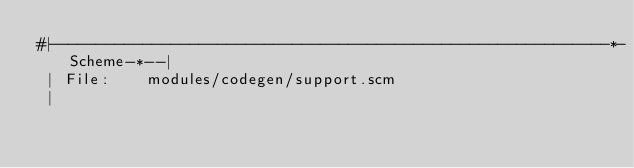Convert code to text. <code><loc_0><loc_0><loc_500><loc_500><_Scheme_>#|------------------------------------------------------------*-Scheme-*--|
 | File:    modules/codegen/support.scm
 |</code> 